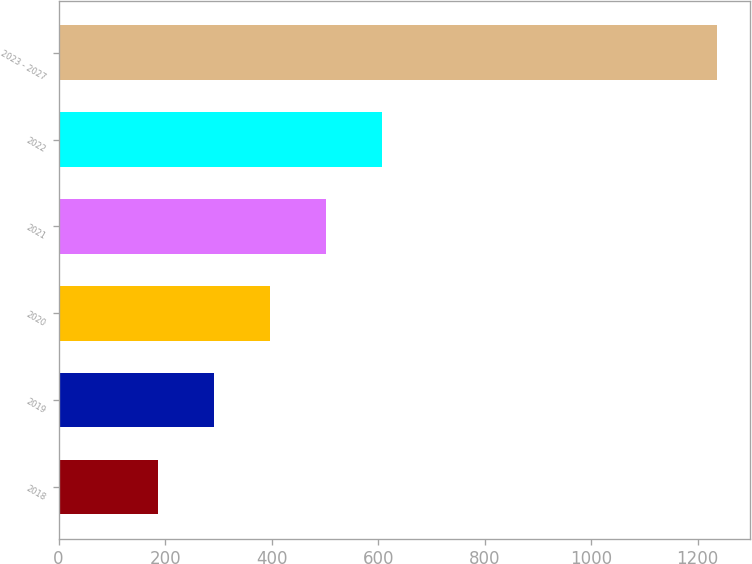Convert chart. <chart><loc_0><loc_0><loc_500><loc_500><bar_chart><fcel>2018<fcel>2019<fcel>2020<fcel>2021<fcel>2022<fcel>2023 - 2027<nl><fcel>186<fcel>291.1<fcel>396.2<fcel>501.3<fcel>606.4<fcel>1237<nl></chart> 